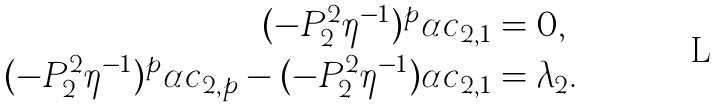Convert formula to latex. <formula><loc_0><loc_0><loc_500><loc_500>( - P _ { 2 } ^ { 2 } \eta ^ { - 1 } ) ^ { p } \alpha c _ { 2 , 1 } & = 0 , \\ ( - P _ { 2 } ^ { 2 } \eta ^ { - 1 } ) ^ { p } \alpha c _ { 2 , p } - ( - P _ { 2 } ^ { 2 } \eta ^ { - 1 } ) \alpha c _ { 2 , 1 } & = \lambda _ { 2 } .</formula> 